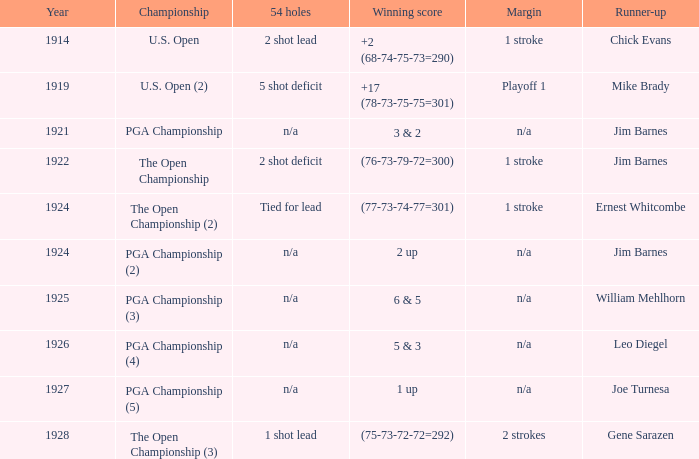HOW MANY YEARS WAS IT FOR THE SCORE (76-73-79-72=300)? 1.0. 